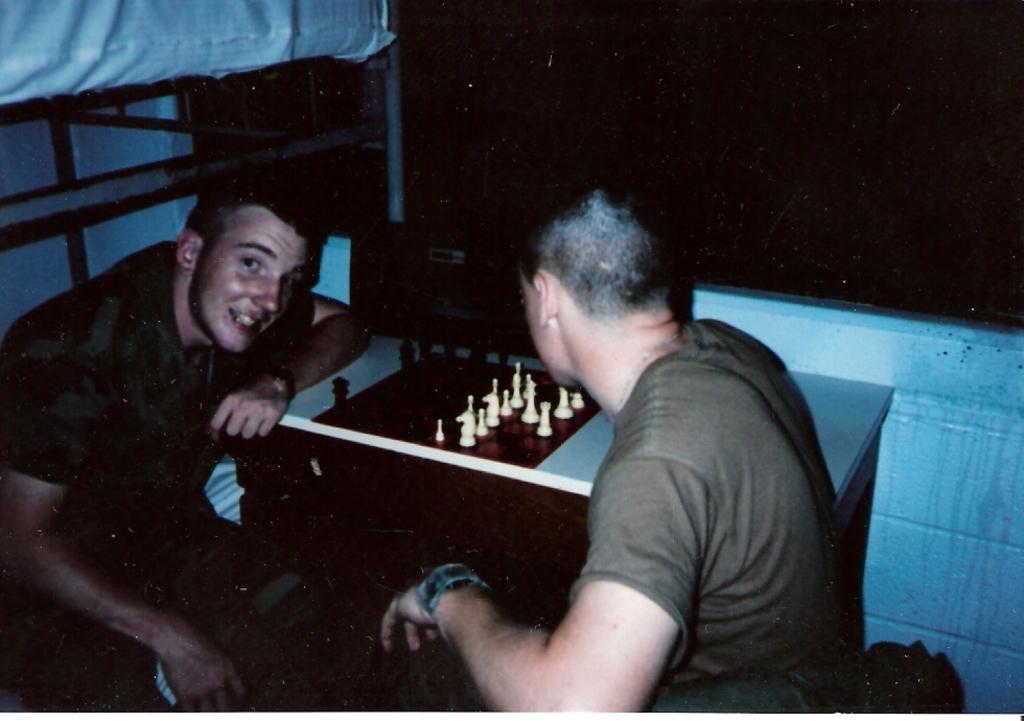Describe this image in one or two sentences. As we can see in the image there are two people sitting. In front of them there is a table. On table there is a chess board and coins. 